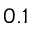Convert formula to latex. <formula><loc_0><loc_0><loc_500><loc_500>0 . 1</formula> 